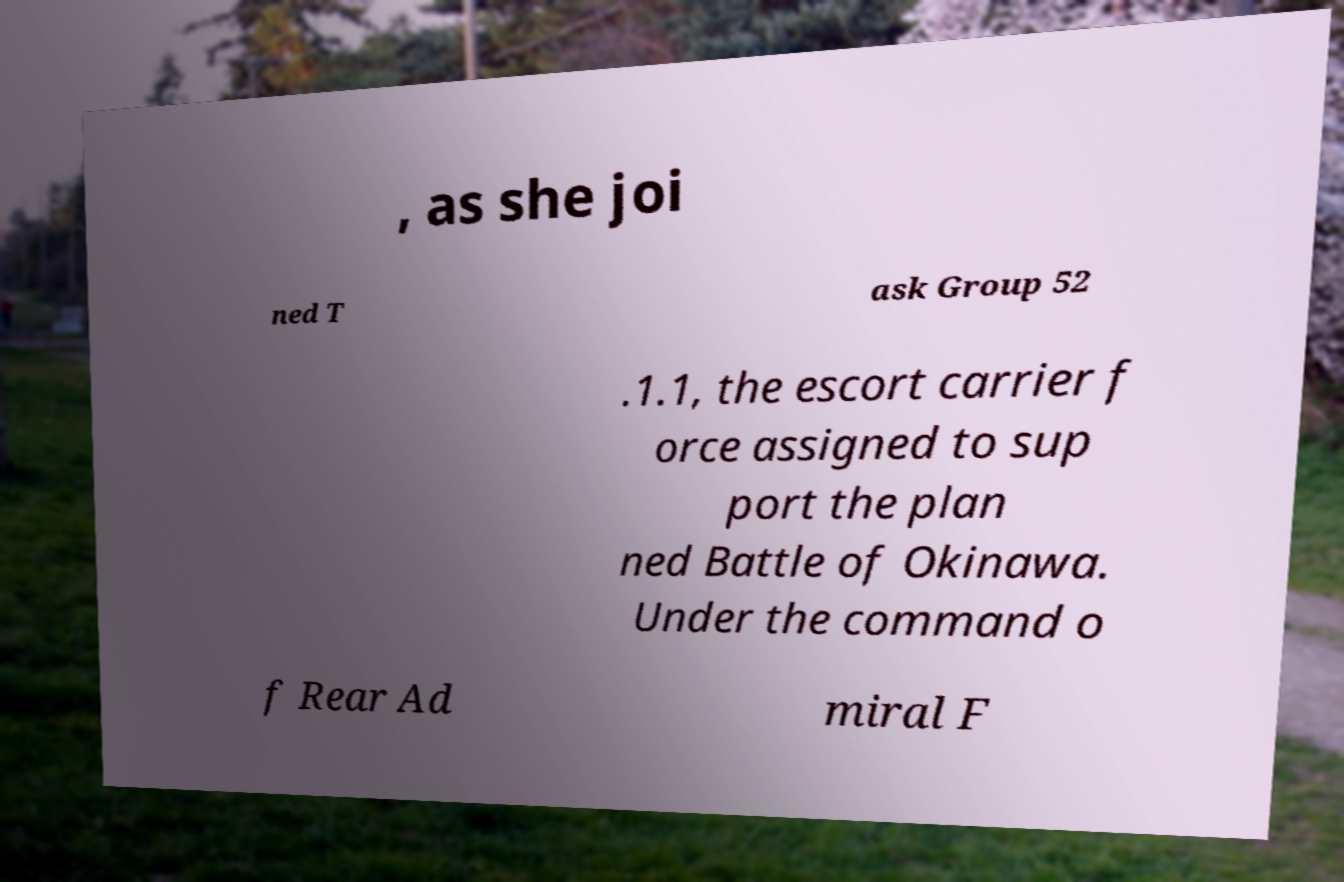Could you assist in decoding the text presented in this image and type it out clearly? , as she joi ned T ask Group 52 .1.1, the escort carrier f orce assigned to sup port the plan ned Battle of Okinawa. Under the command o f Rear Ad miral F 